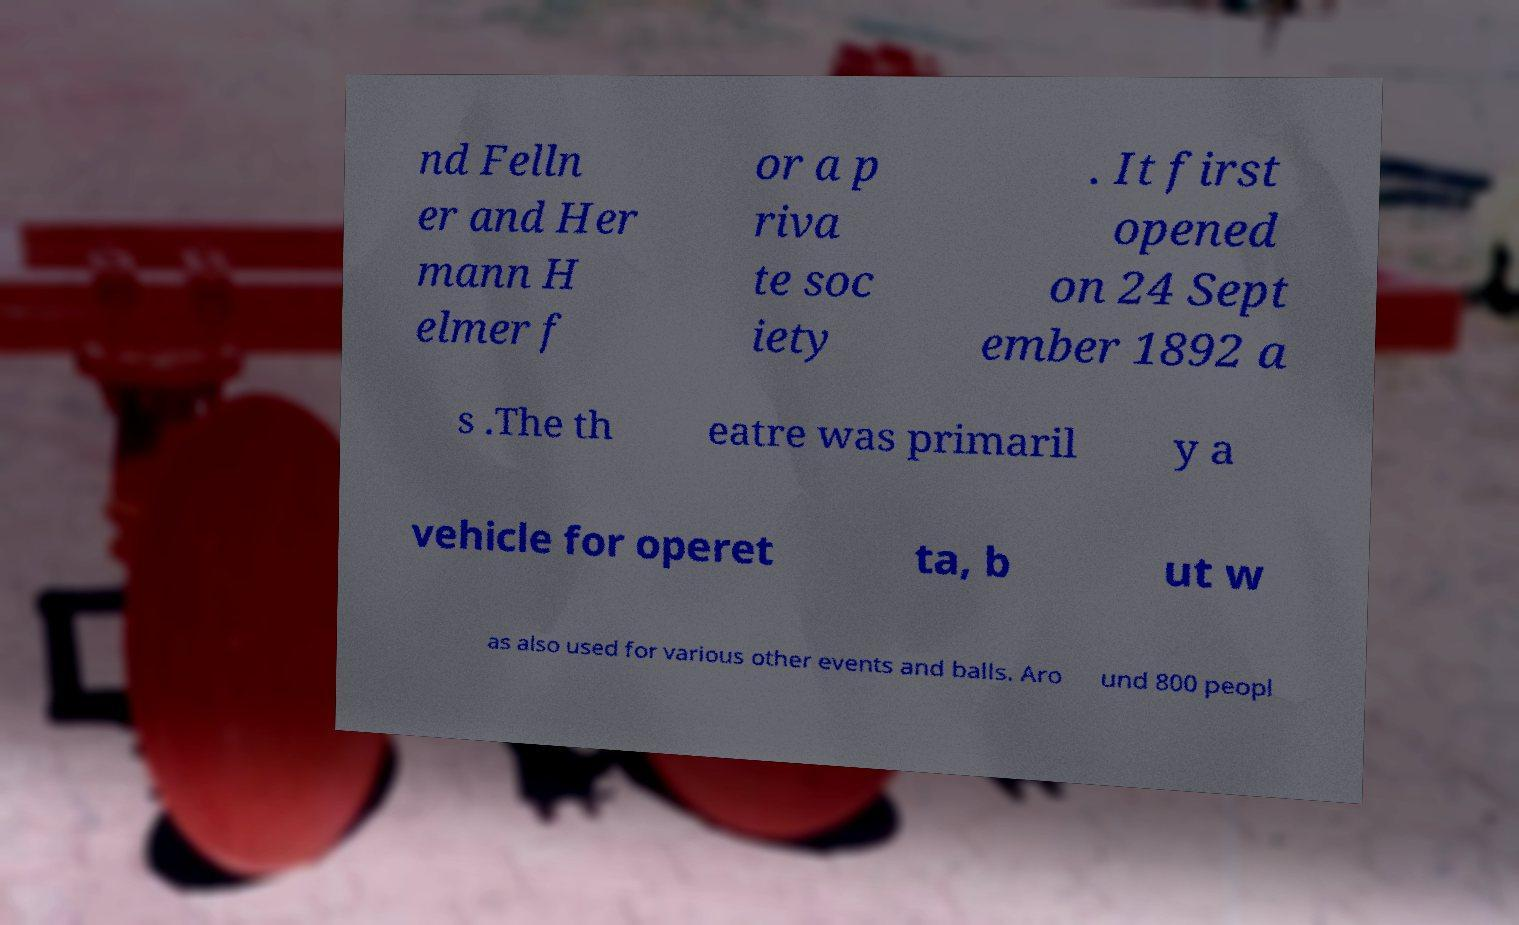Could you extract and type out the text from this image? nd Felln er and Her mann H elmer f or a p riva te soc iety . It first opened on 24 Sept ember 1892 a s .The th eatre was primaril y a vehicle for operet ta, b ut w as also used for various other events and balls. Aro und 800 peopl 